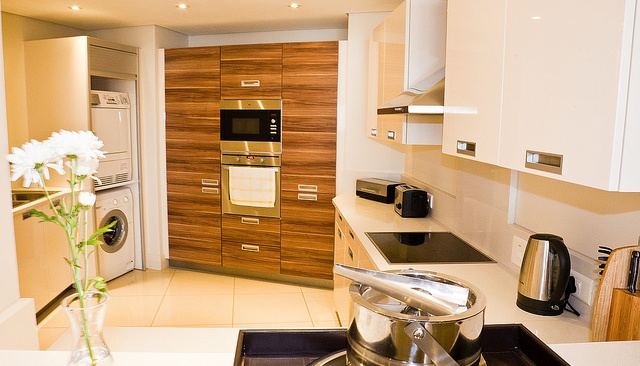Describe the objects in this image and their specific colors. I can see oven in tan, ivory, olive, and orange tones, microwave in tan, black, orange, and olive tones, sink in tan, black, brown, and maroon tones, vase in tan, ivory, and khaki tones, and toaster in tan, black, and olive tones in this image. 